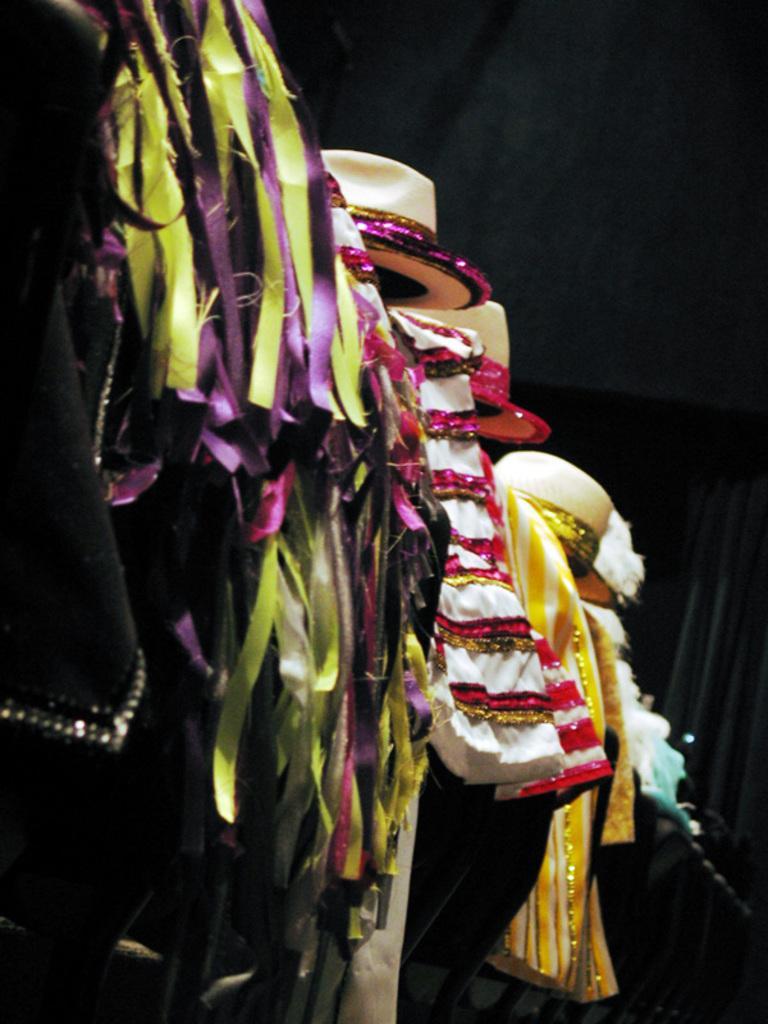Can you describe this image briefly? In this image we can see hats and clothes. There is a dark background. 